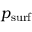<formula> <loc_0><loc_0><loc_500><loc_500>p _ { s u r f }</formula> 